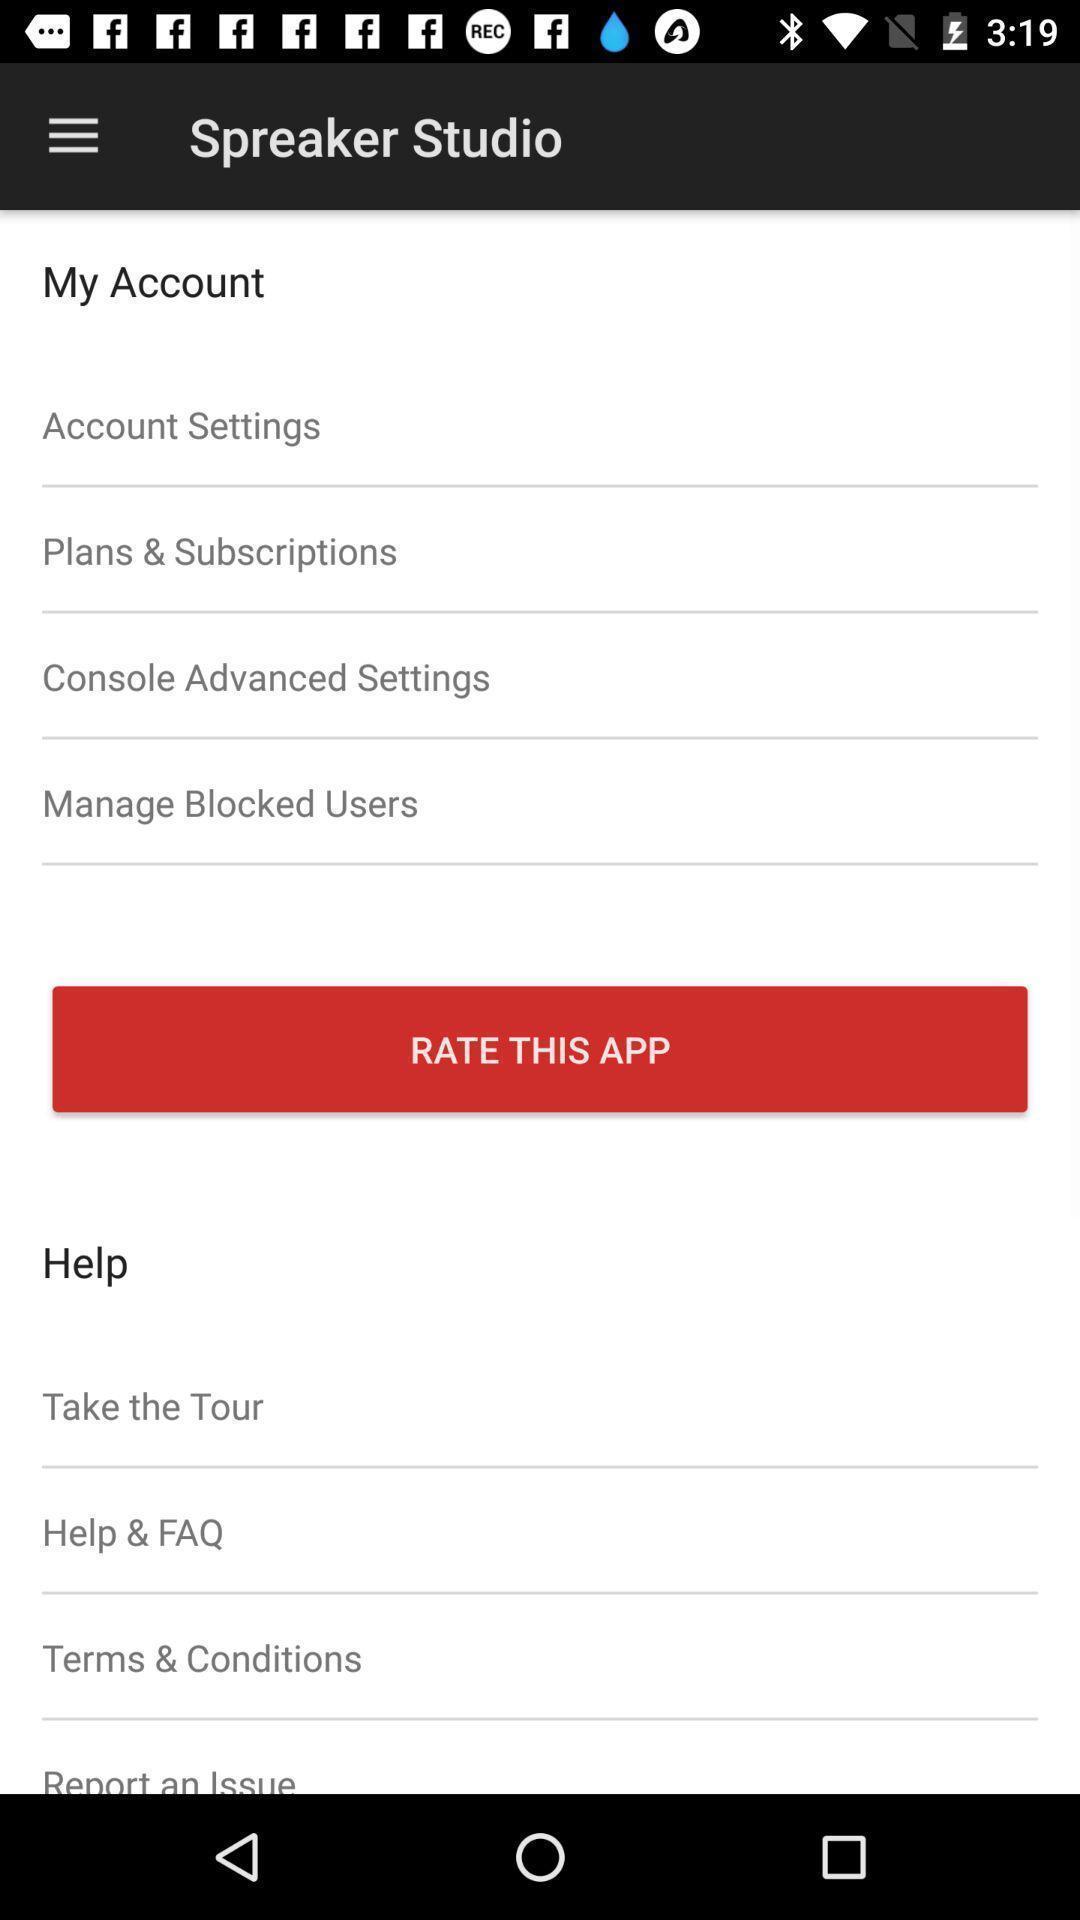Explain the elements present in this screenshot. Page showing the options for settings and rating. 